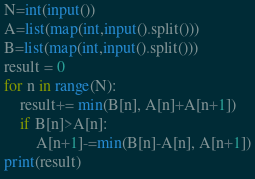<code> <loc_0><loc_0><loc_500><loc_500><_Python_>N=int(input())
A=list(map(int,input().split()))
B=list(map(int,input().split()))
result = 0
for n in range(N):
    result+= min(B[n], A[n]+A[n+1])
    if B[n]>A[n]:
        A[n+1]-=min(B[n]-A[n], A[n+1])
print(result)</code> 